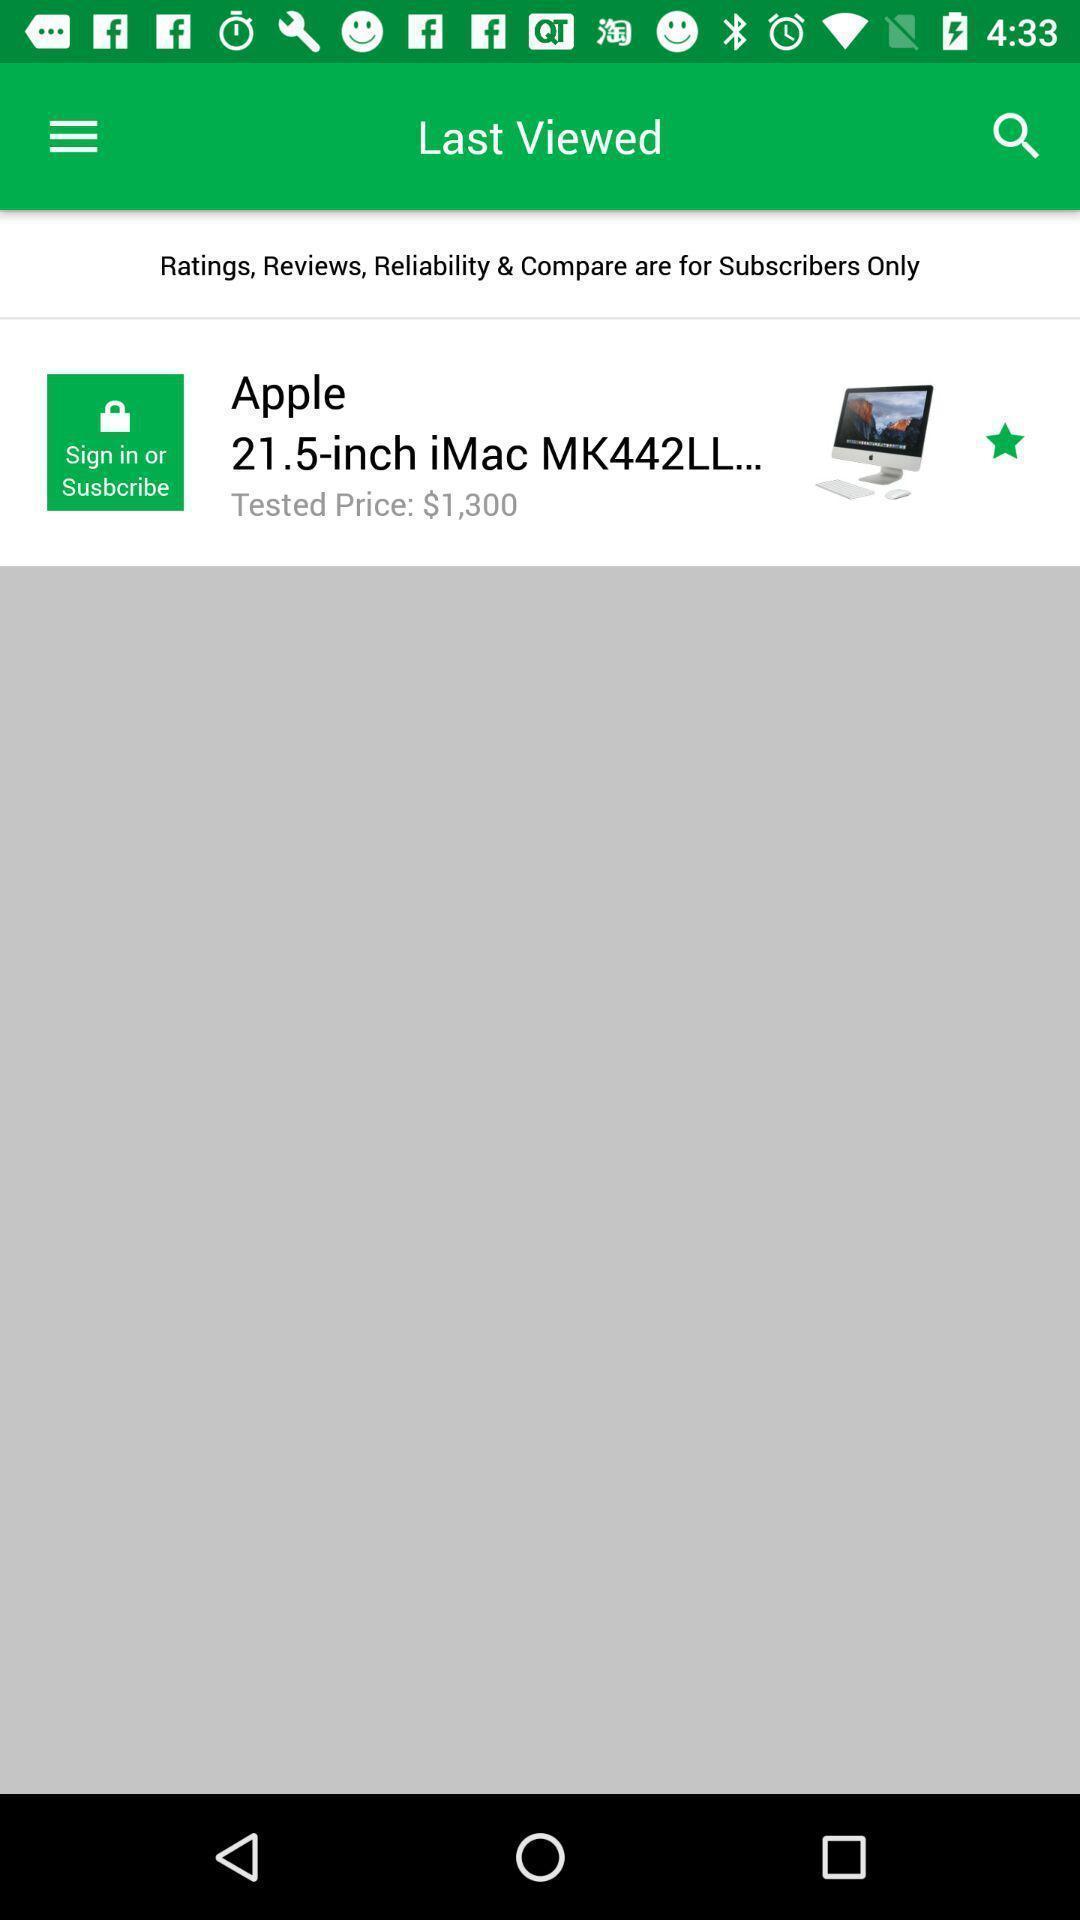What is the overall content of this screenshot? Page shows product information in shopping app. 